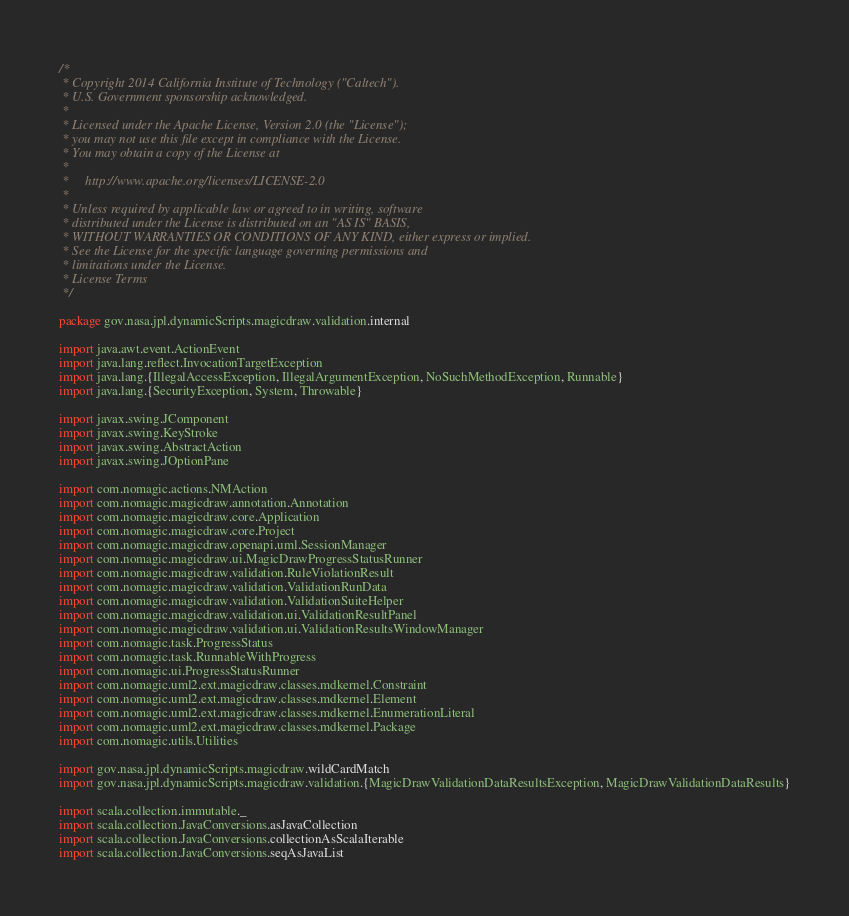Convert code to text. <code><loc_0><loc_0><loc_500><loc_500><_Scala_>/*
 * Copyright 2014 California Institute of Technology ("Caltech").
 * U.S. Government sponsorship acknowledged.
 *
 * Licensed under the Apache License, Version 2.0 (the "License");
 * you may not use this file except in compliance with the License.
 * You may obtain a copy of the License at
 *
 *     http://www.apache.org/licenses/LICENSE-2.0
 *
 * Unless required by applicable law or agreed to in writing, software
 * distributed under the License is distributed on an "AS IS" BASIS,
 * WITHOUT WARRANTIES OR CONDITIONS OF ANY KIND, either express or implied.
 * See the License for the specific language governing permissions and
 * limitations under the License.
 * License Terms
 */

package gov.nasa.jpl.dynamicScripts.magicdraw.validation.internal

import java.awt.event.ActionEvent
import java.lang.reflect.InvocationTargetException
import java.lang.{IllegalAccessException, IllegalArgumentException, NoSuchMethodException, Runnable}
import java.lang.{SecurityException, System, Throwable}

import javax.swing.JComponent
import javax.swing.KeyStroke
import javax.swing.AbstractAction
import javax.swing.JOptionPane

import com.nomagic.actions.NMAction
import com.nomagic.magicdraw.annotation.Annotation
import com.nomagic.magicdraw.core.Application
import com.nomagic.magicdraw.core.Project
import com.nomagic.magicdraw.openapi.uml.SessionManager
import com.nomagic.magicdraw.ui.MagicDrawProgressStatusRunner
import com.nomagic.magicdraw.validation.RuleViolationResult
import com.nomagic.magicdraw.validation.ValidationRunData
import com.nomagic.magicdraw.validation.ValidationSuiteHelper
import com.nomagic.magicdraw.validation.ui.ValidationResultPanel
import com.nomagic.magicdraw.validation.ui.ValidationResultsWindowManager
import com.nomagic.task.ProgressStatus
import com.nomagic.task.RunnableWithProgress
import com.nomagic.ui.ProgressStatusRunner
import com.nomagic.uml2.ext.magicdraw.classes.mdkernel.Constraint
import com.nomagic.uml2.ext.magicdraw.classes.mdkernel.Element
import com.nomagic.uml2.ext.magicdraw.classes.mdkernel.EnumerationLiteral
import com.nomagic.uml2.ext.magicdraw.classes.mdkernel.Package
import com.nomagic.utils.Utilities

import gov.nasa.jpl.dynamicScripts.magicdraw.wildCardMatch
import gov.nasa.jpl.dynamicScripts.magicdraw.validation.{MagicDrawValidationDataResultsException, MagicDrawValidationDataResults}

import scala.collection.immutable._
import scala.collection.JavaConversions.asJavaCollection
import scala.collection.JavaConversions.collectionAsScalaIterable
import scala.collection.JavaConversions.seqAsJavaList</code> 